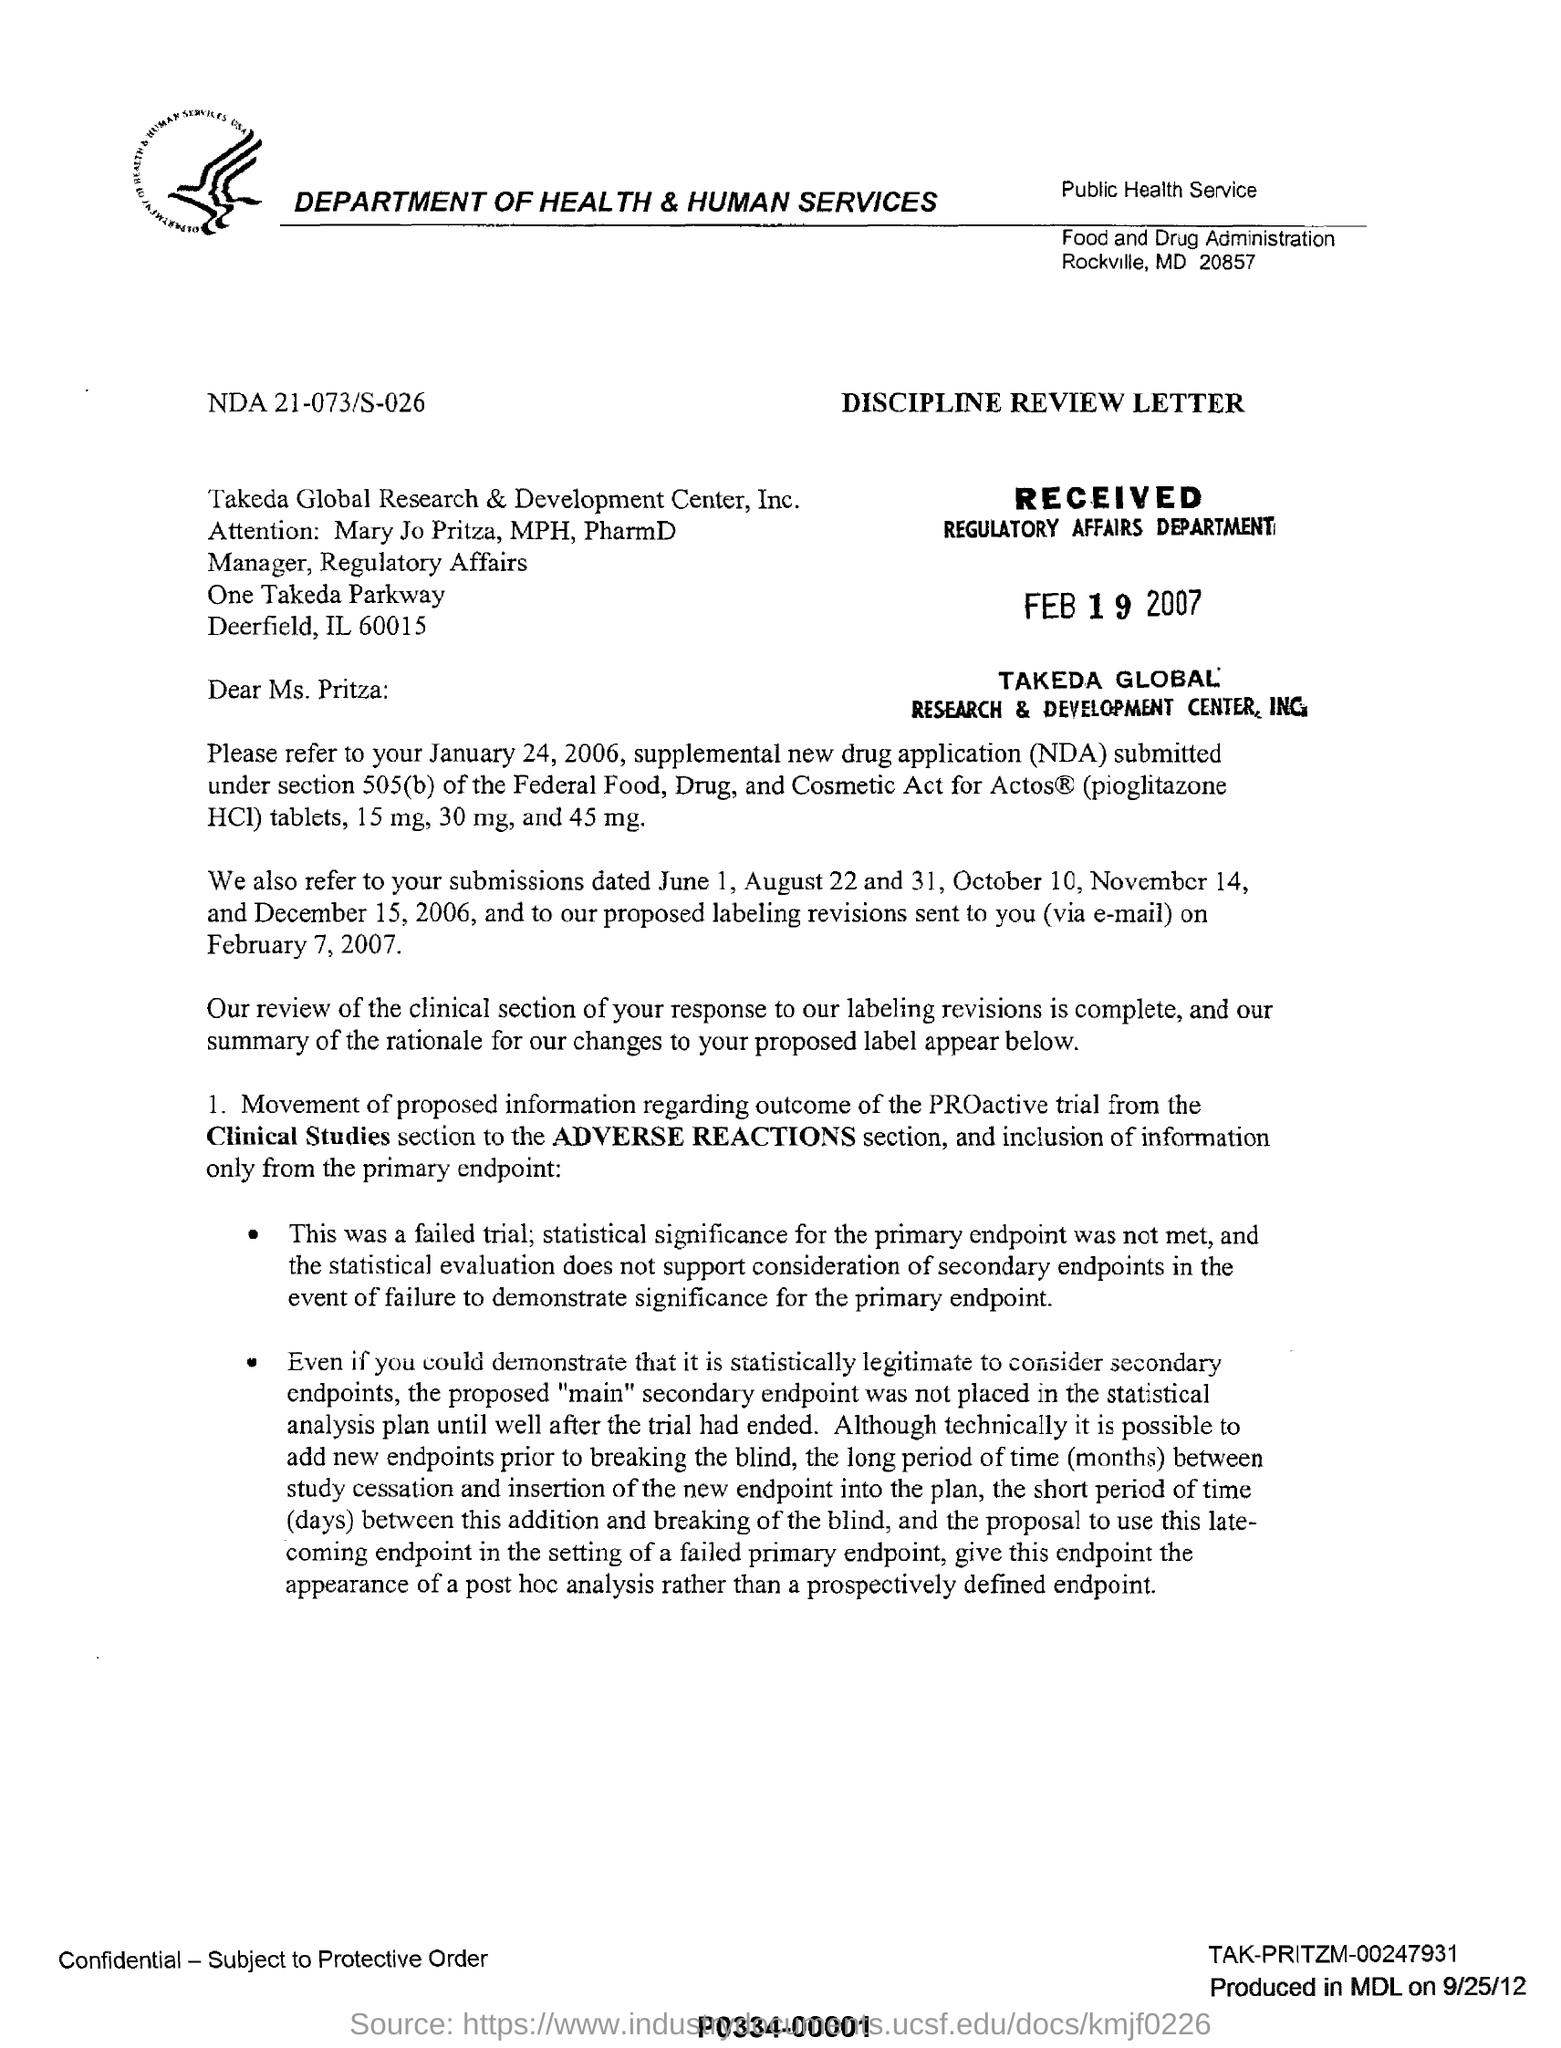What is the name of the company mentioned in the letterhead?
Your answer should be compact. DEPARTMENT OF HEALTH & HUMAN SERVICES. What is the fullform of NDA?
Make the answer very short. New drug application. What is the name of the addressee?
Your response must be concise. Ms. Pritza. What kind of a letter is  this ?
Your answer should be very brief. DISCIPLINE REVIEW LETTER. When did Regulatory affairs department receive this letter?
Provide a succinct answer. Feb 19 2007. 